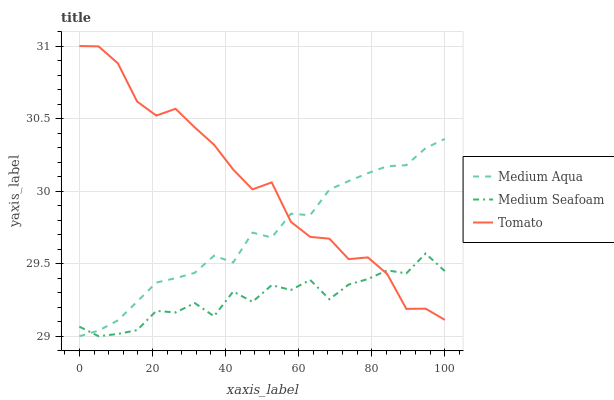Does Medium Seafoam have the minimum area under the curve?
Answer yes or no. Yes. Does Tomato have the maximum area under the curve?
Answer yes or no. Yes. Does Medium Aqua have the minimum area under the curve?
Answer yes or no. No. Does Medium Aqua have the maximum area under the curve?
Answer yes or no. No. Is Medium Aqua the smoothest?
Answer yes or no. Yes. Is Medium Seafoam the roughest?
Answer yes or no. Yes. Is Medium Seafoam the smoothest?
Answer yes or no. No. Is Medium Aqua the roughest?
Answer yes or no. No. Does Tomato have the highest value?
Answer yes or no. Yes. Does Medium Aqua have the highest value?
Answer yes or no. No. Does Tomato intersect Medium Aqua?
Answer yes or no. Yes. Is Tomato less than Medium Aqua?
Answer yes or no. No. Is Tomato greater than Medium Aqua?
Answer yes or no. No. 